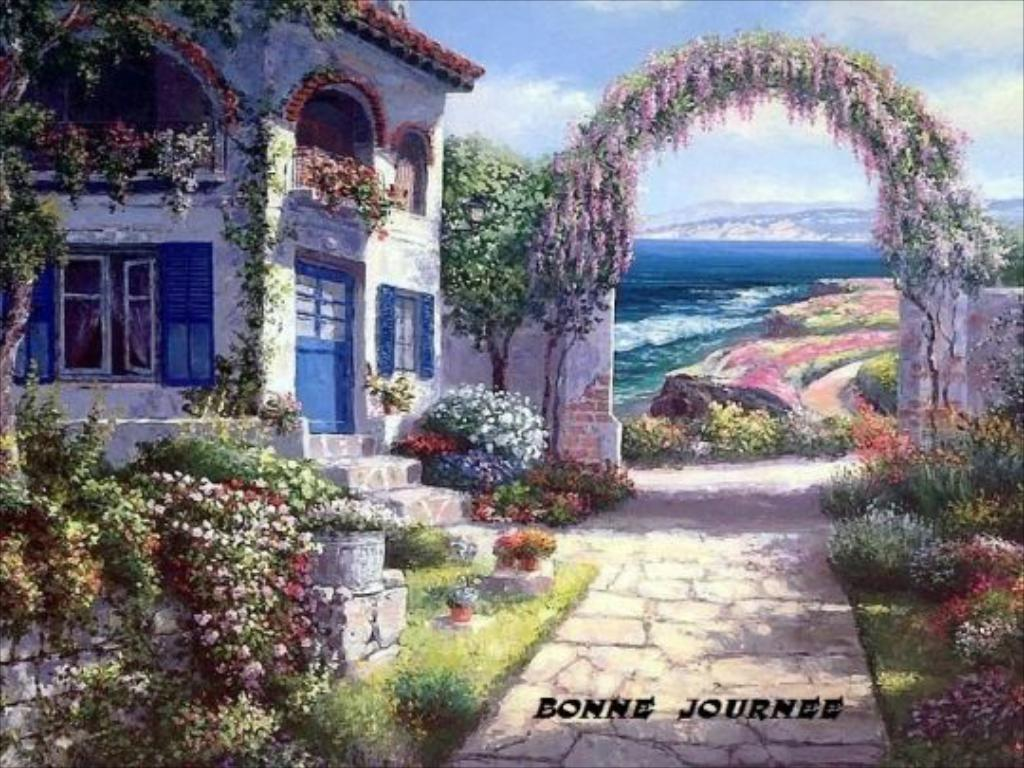What type of artwork is the image? The image is a painted picture. What is the main subject of the painting? There is a building in the image. What other elements are present in the painting? There are trees, plants with flowers, water, a wall with an arch, and a blue and cloudy sky visible in the image. Who is the creator of the houses in the image? There are no houses present in the image; it features a building, trees, plants with flowers, water, a wall with an arch, and a blue and cloudy sky. 